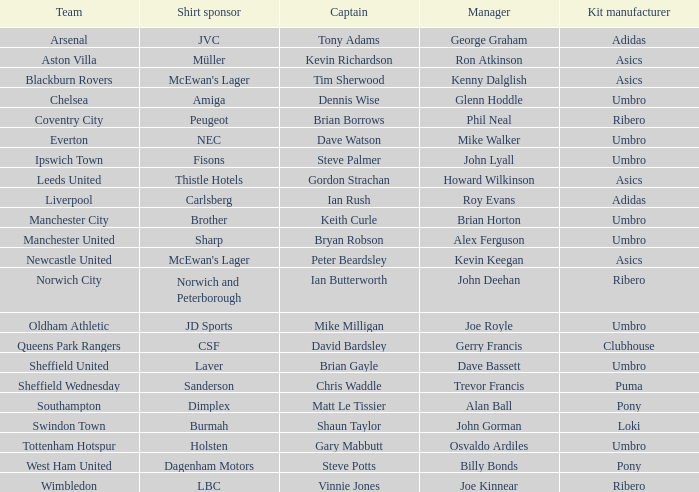Which manager has sheffield wednesday as the team? Trevor Francis. 